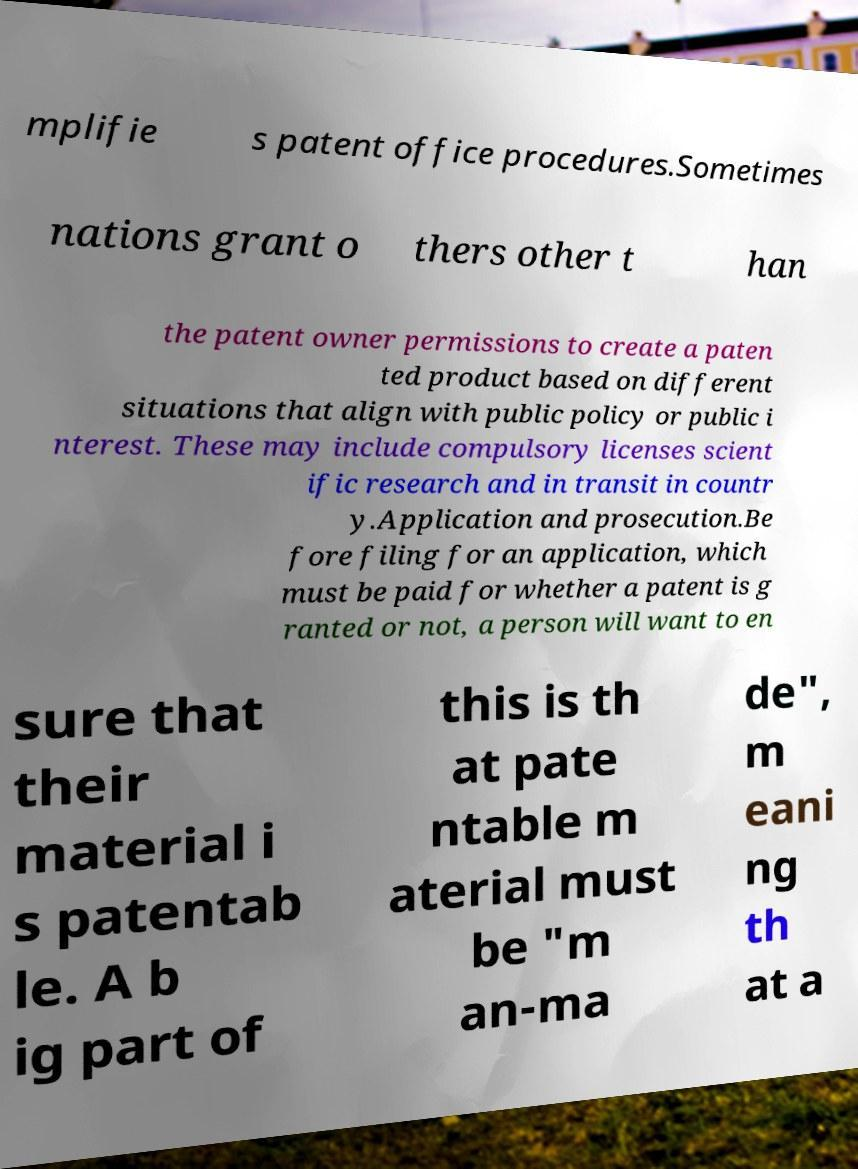I need the written content from this picture converted into text. Can you do that? mplifie s patent office procedures.Sometimes nations grant o thers other t han the patent owner permissions to create a paten ted product based on different situations that align with public policy or public i nterest. These may include compulsory licenses scient ific research and in transit in countr y.Application and prosecution.Be fore filing for an application, which must be paid for whether a patent is g ranted or not, a person will want to en sure that their material i s patentab le. A b ig part of this is th at pate ntable m aterial must be "m an-ma de", m eani ng th at a 